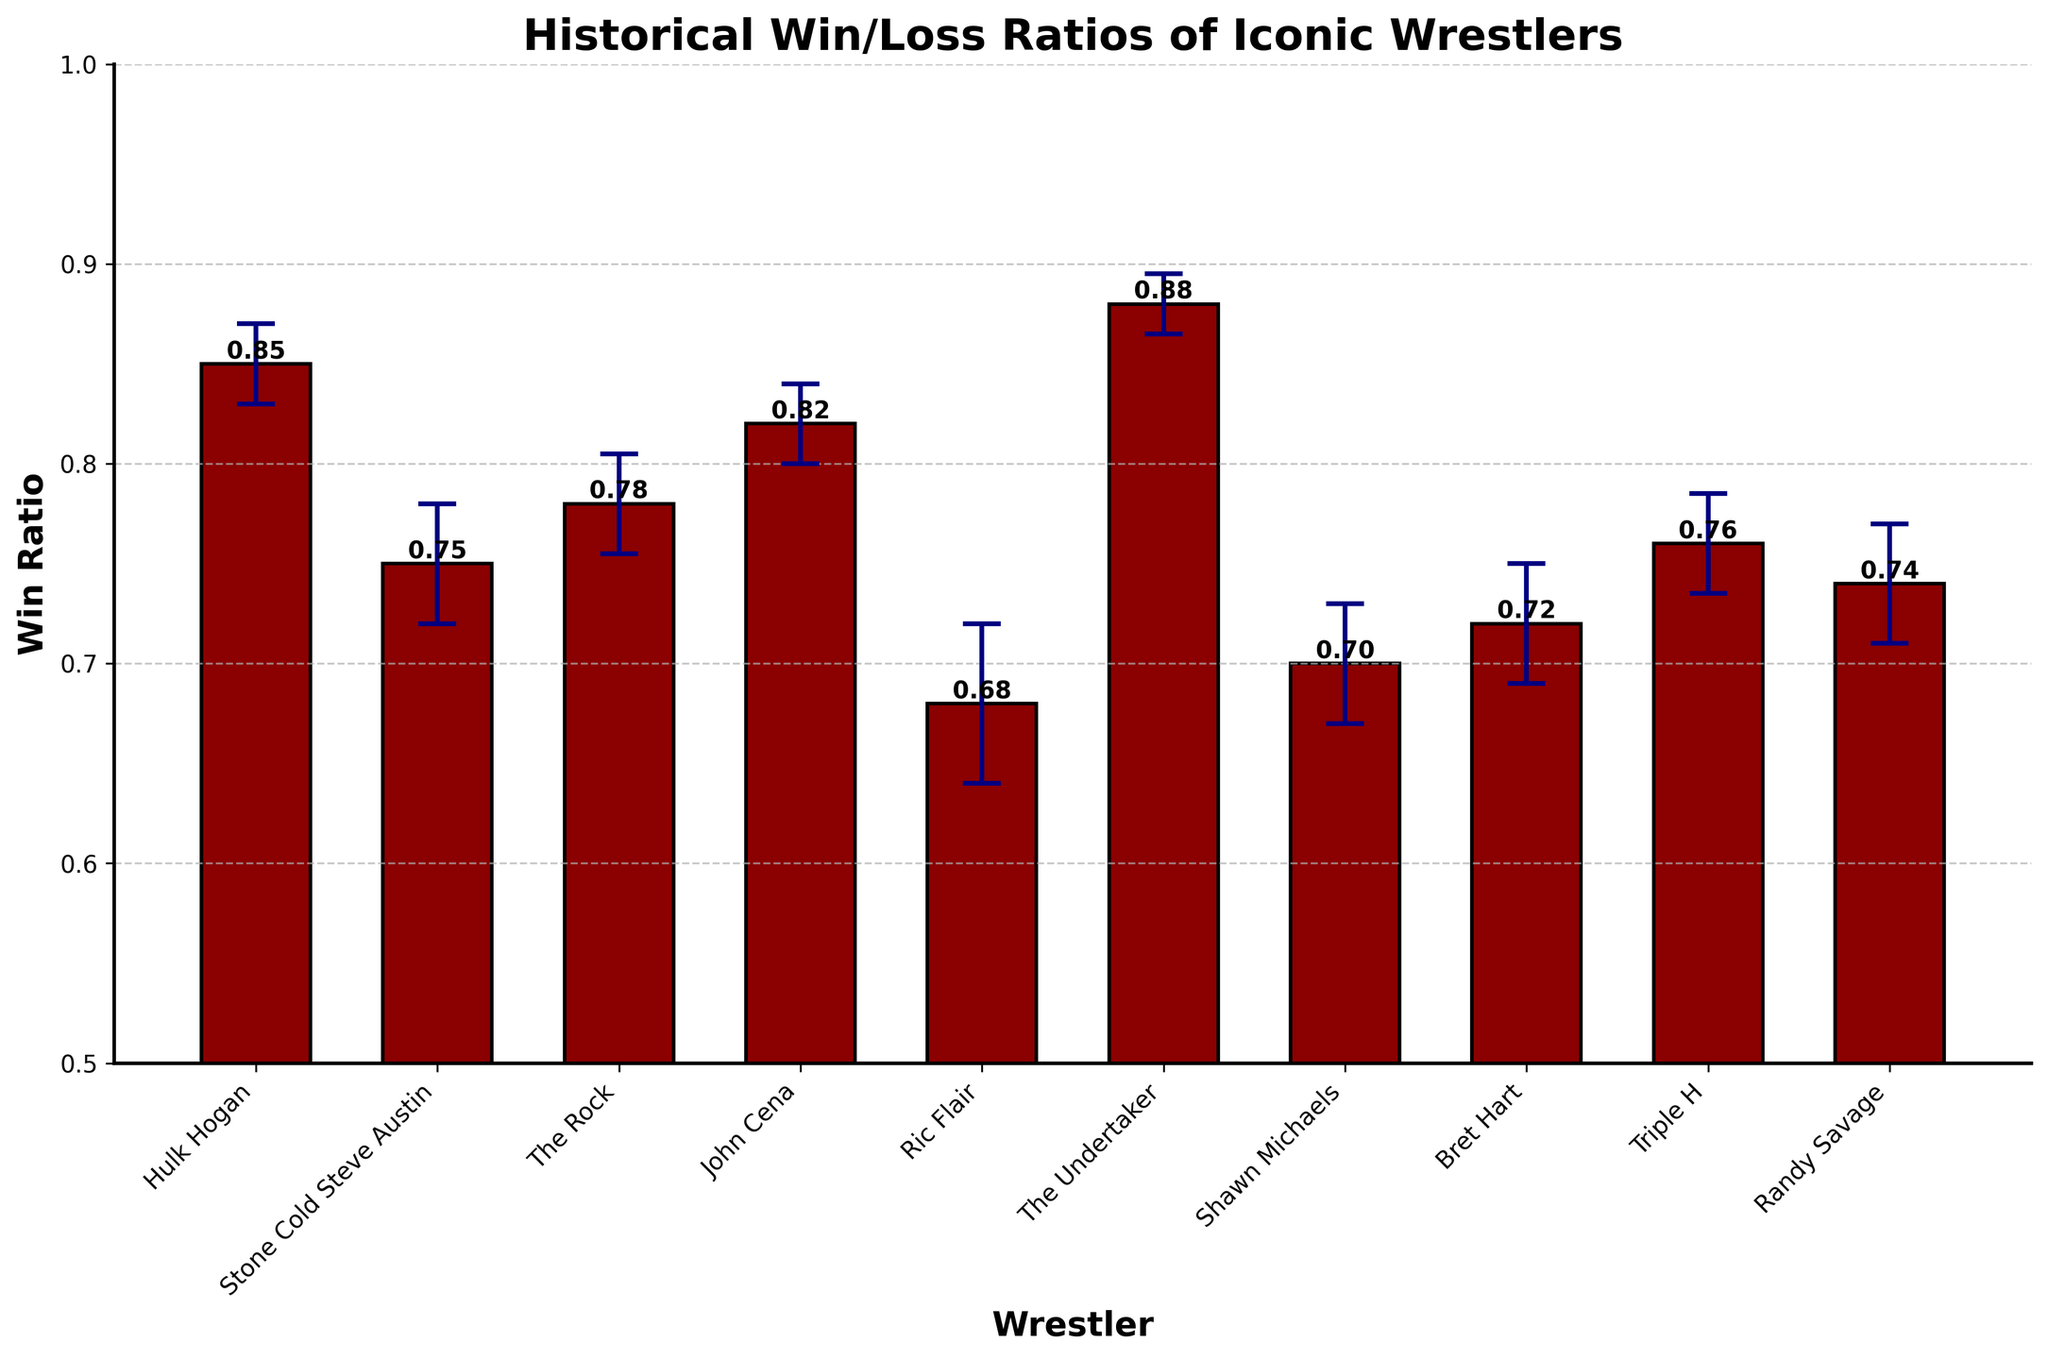What's the range of win ratios displayed in the chart? The chart displays win ratios for various wrestlers, ranging from Ric Flair with the lowest win ratio of 0.68 to The Undertaker with the highest win ratio of 0.88.
Answer: 0.68 - 0.88 How many wrestlers have a win ratio of at least 0.80? From the chart, we see that Hulk Hogan (0.85), John Cena (0.82), and The Undertaker (0.88) all have win ratios of at least 0.80.
Answer: 3 Which wrestler has the highest win ratio, and what is it? The Undertaker has the highest win ratio in the chart with a ratio of 0.88.
Answer: The Undertaker, 0.88 Which two wrestlers have the closest win ratios? The win ratio of Randy Savage (0.74) and Stone Cold Steve Austin (0.75) are the closest, differing by only 0.01.
Answer: Randy Savage and Stone Cold Steve Austin What is the win ratio of Bret Hart? The win ratio of Bret Hart as shown in the chart is 0.72.
Answer: 0.72 What is the average win ratio of the wrestlers listed? Sum the win ratios of all wrestlers and divide by the number of wrestlers: (0.85 + 0.75 + 0.78 + 0.82 + 0.68 + 0.88 + 0.7 + 0.72 + 0.76 + 0.74) / 10 = 7.68 / 10 = 0.768.
Answer: 0.768 Based on the chart, which wrestler appears to be the most statistically confident in their shown win ratio? The confidence interval (error bar) is the smallest for The Undertaker, indicating the highest statistical confidence in their win ratio of 0.88.
Answer: The Undertaker What’s the total span of the error bars for Hulk Hogan and Ric Flair? The error bar span for Hulk Hogan is 0.02 and for Ric Flair is 0.04. Adding these together: 0.02 + 0.04 = 0.06.
Answer: 0.06 Which wrestler has a lower win ratio: Shawn Michaels or Bret Hart? Shawn Michaels has a win ratio of 0.70, while Bret Hart has a win ratio of 0.72. Therefore, Shawn Michaels has the lower win ratio.
Answer: Shawn Michaels How much higher is John Cena's win ratio compared to Triple H's? John Cena has a win ratio of 0.82 and Triple H has a win ratio of 0.76. The difference is 0.82 - 0.76 = 0.06.
Answer: 0.06 